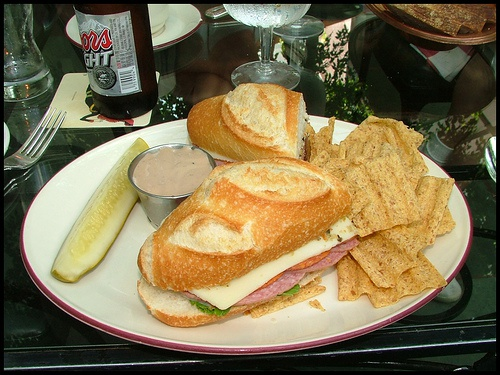Describe the objects in this image and their specific colors. I can see sandwich in black, orange, and khaki tones, sandwich in black, olive, tan, khaki, and orange tones, bottle in black, darkgray, and gray tones, bowl in black, tan, and gray tones, and cup in black, teal, and darkgreen tones in this image. 